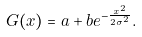Convert formula to latex. <formula><loc_0><loc_0><loc_500><loc_500>G ( x ) = a + b e ^ { - \frac { x ^ { 2 } } { 2 \sigma ^ { 2 } } } .</formula> 